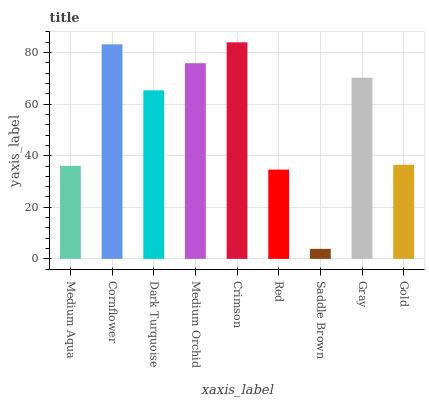Is Saddle Brown the minimum?
Answer yes or no. Yes. Is Crimson the maximum?
Answer yes or no. Yes. Is Cornflower the minimum?
Answer yes or no. No. Is Cornflower the maximum?
Answer yes or no. No. Is Cornflower greater than Medium Aqua?
Answer yes or no. Yes. Is Medium Aqua less than Cornflower?
Answer yes or no. Yes. Is Medium Aqua greater than Cornflower?
Answer yes or no. No. Is Cornflower less than Medium Aqua?
Answer yes or no. No. Is Dark Turquoise the high median?
Answer yes or no. Yes. Is Dark Turquoise the low median?
Answer yes or no. Yes. Is Saddle Brown the high median?
Answer yes or no. No. Is Crimson the low median?
Answer yes or no. No. 